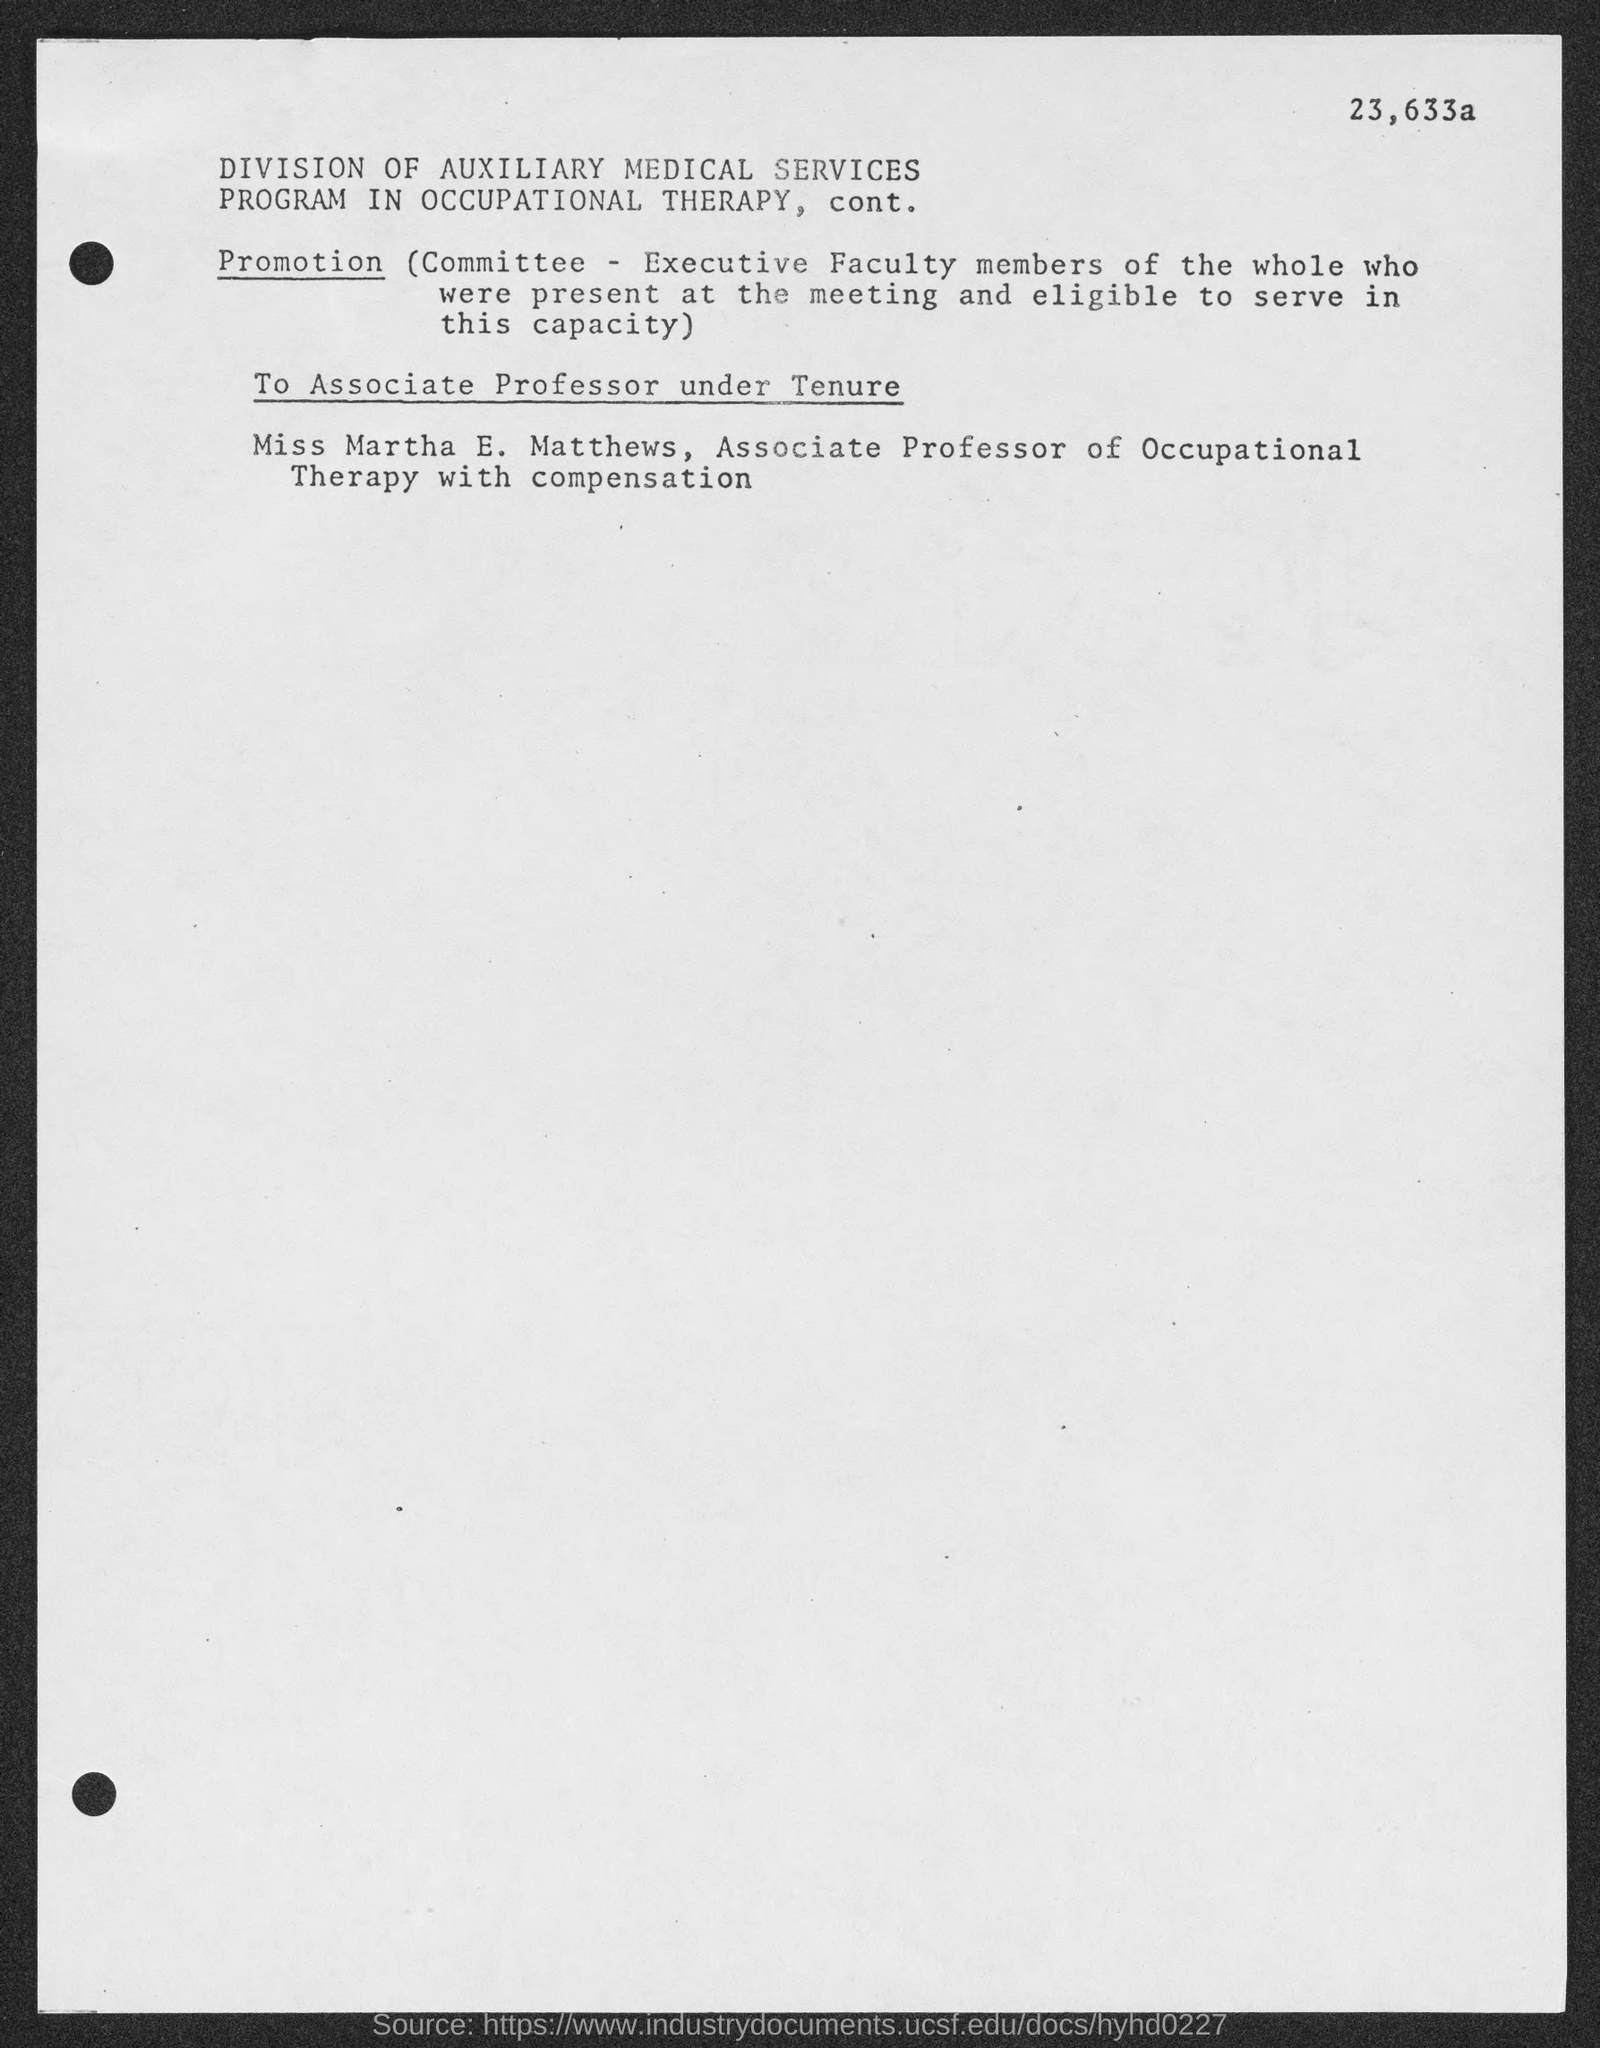Who is the associate professor of occupational therapy with compensation?
Offer a very short reply. Miss Martha E. Matthews. 